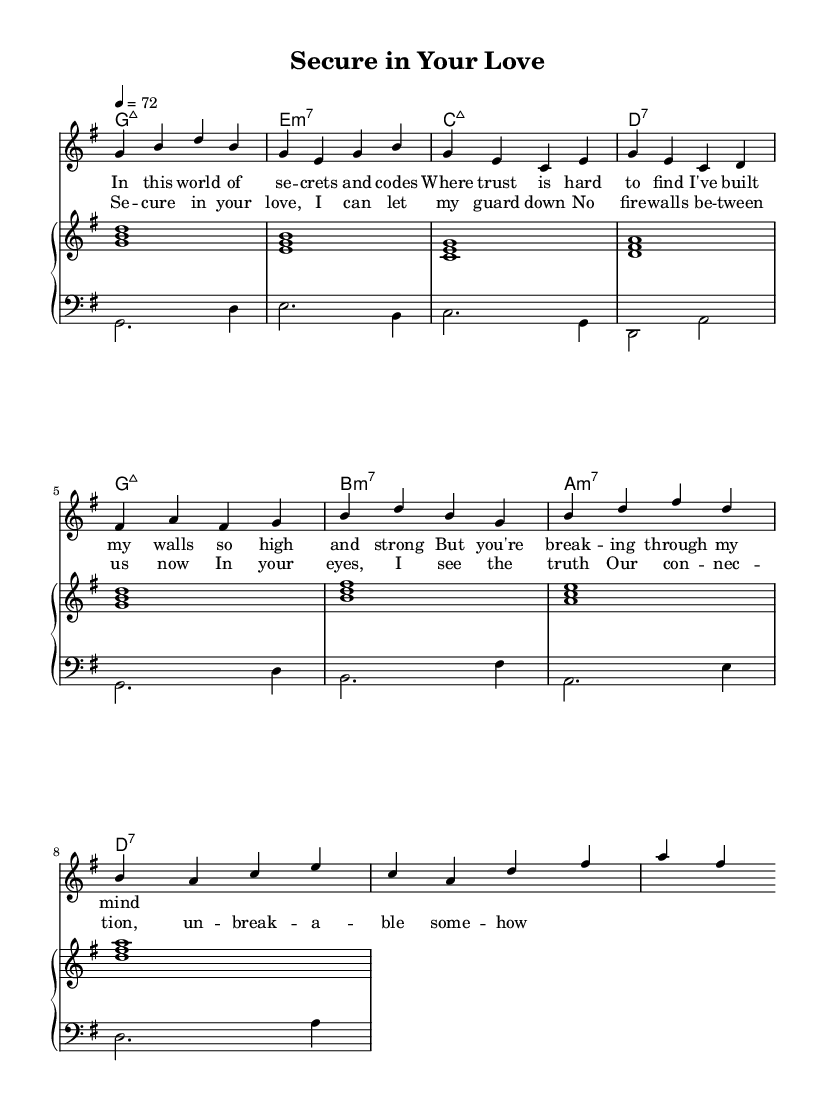What is the key signature of this music? The key signature is G major, which includes one sharp (F#).
Answer: G major What is the time signature of this music? The time signature is 4/4, indicating four beats per measure.
Answer: 4/4 What is the tempo marking indicated in the score? The tempo marking is set to 72 beats per minute, which guides the speed of the performance.
Answer: 72 What is the primary theme explored in the lyrics? The primary theme in the lyrics is about trust and security in a relationship, focusing on emotional vulnerability.
Answer: Trust and security How many chords are used in the verse section? The verse section utilizes four chords: G major 7, E minor 7, C major 7, and D7.
Answer: Four chords What type of harmony is predominantly used in this ballad? The harmony is characterized by seventh chords, which are common in Rhythm and Blues music, creating a rich and lush sound.
Answer: Seventh chords What is the style of this music piece? The style of the music piece is a smooth R&B ballad, known for its soulful melodies and emotional depth.
Answer: Smooth R&B ballad 